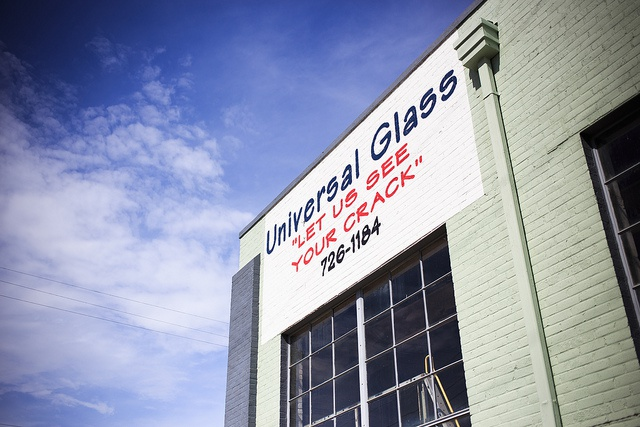Describe the objects in this image and their specific colors. I can see various objects in this image with different colors. 